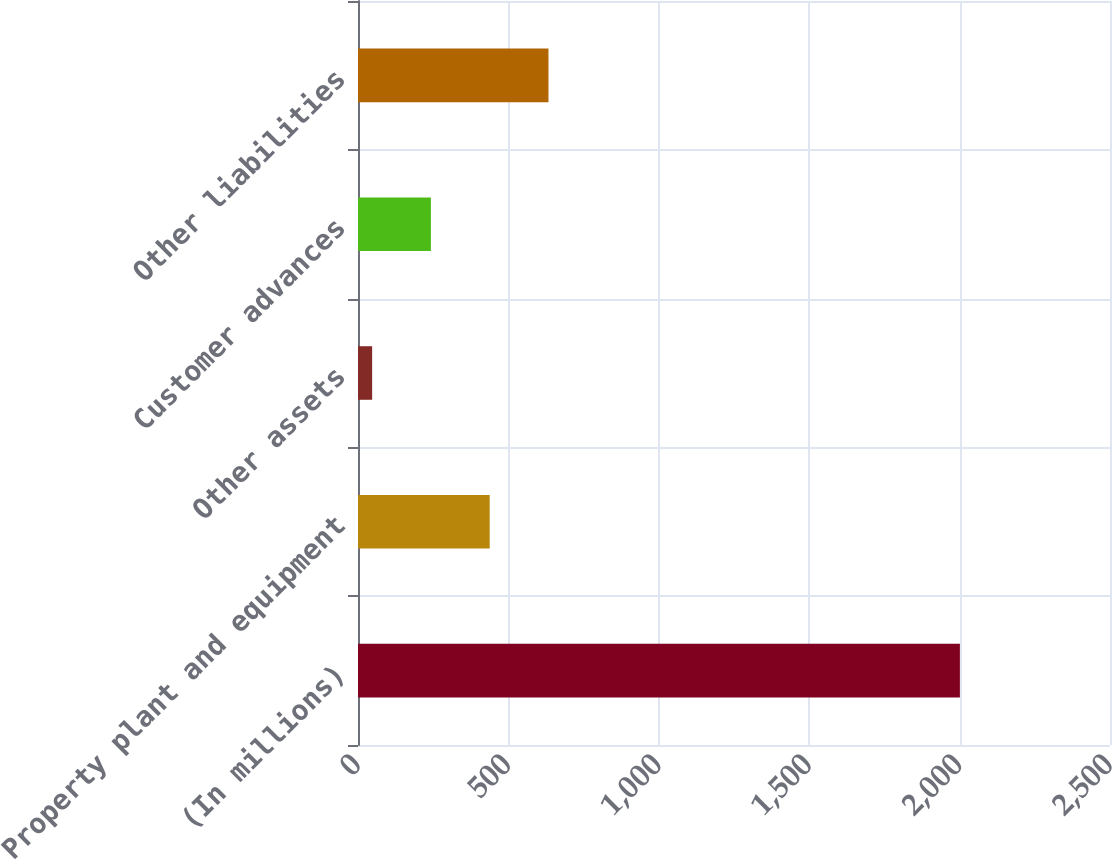Convert chart to OTSL. <chart><loc_0><loc_0><loc_500><loc_500><bar_chart><fcel>(In millions)<fcel>Property plant and equipment<fcel>Other assets<fcel>Customer advances<fcel>Other liabilities<nl><fcel>2001<fcel>437.8<fcel>47<fcel>242.4<fcel>633.2<nl></chart> 